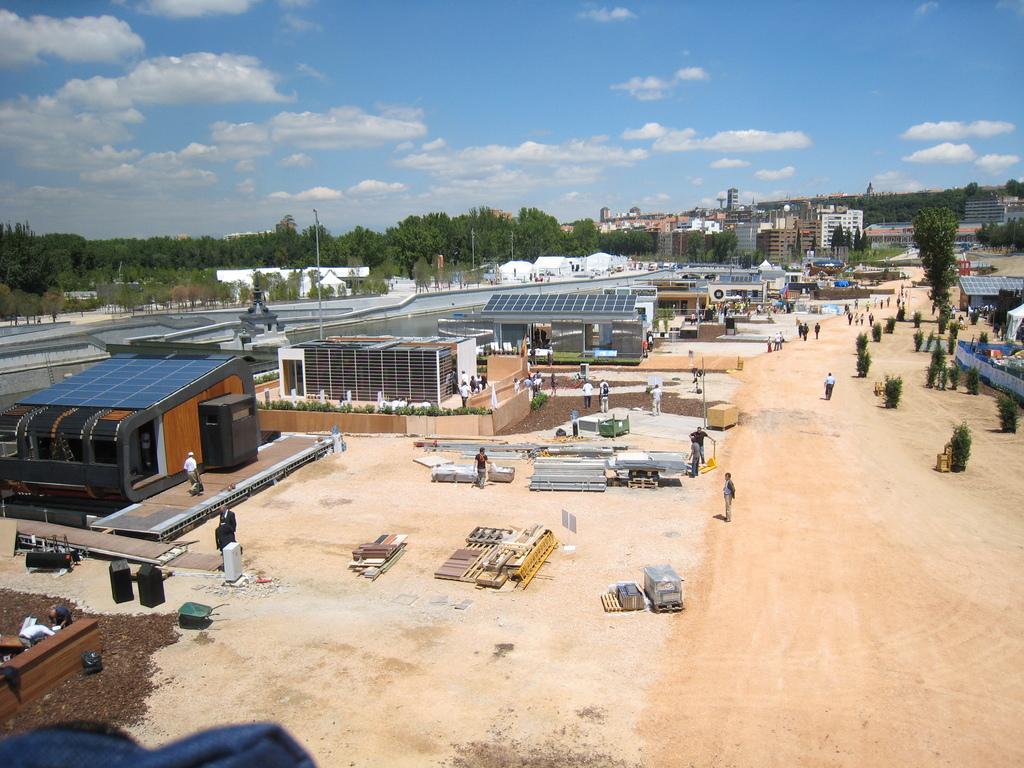Could you give a brief overview of what you see in this image? In the image we can see there are factories and buildings. There are iron items kept on the ground and there are people standing on the ground. Behind there are lot of trees. 